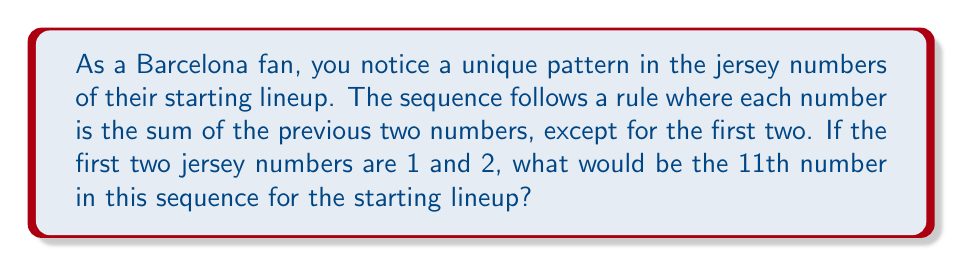Can you solve this math problem? Let's approach this step-by-step:

1) First, let's write out the sequence based on the given rule:
   $1, 2, 3, 5, 8, 13, 21, 34, 55, 89, ...$

2) We can see that this is the famous Fibonacci sequence, where each number is the sum of the two preceding ones.

3) To find the 11th number, we need to continue the sequence:
   - 9th number: 55
   - 10th number: 89
   - 11th number: $55 + 89 = 144$

4) We can verify this using the Fibonacci formula:
   $F_n = F_{n-1} + F_{n-2}$

   Where $F_n$ is the nth Fibonacci number.

5) For the 11th number:
   $F_{11} = F_{10} + F_9 = 89 + 55 = 144$

Therefore, the 11th number in the sequence would be 144.
Answer: 144 